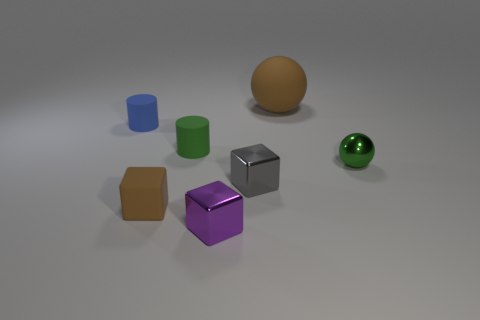Are there any patterns or symmetry in the arrangement of these objects? The objects are arranged without a clear pattern or symmetry. They are placed at varying distances from each other, and their sizes and colors do not follow a repetitive sequence. 